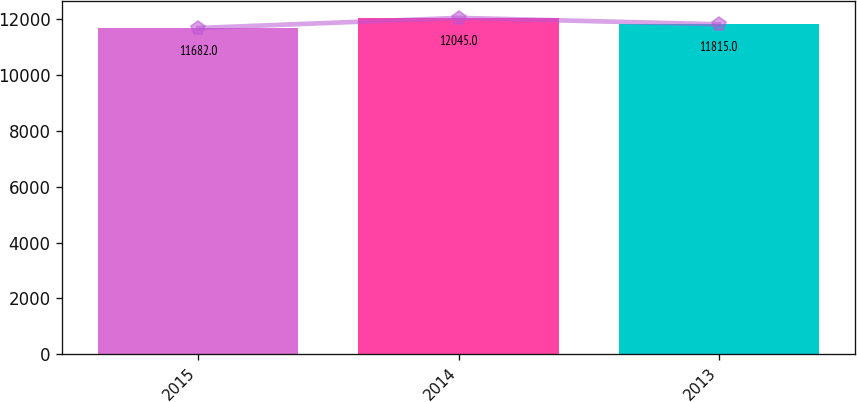Convert chart. <chart><loc_0><loc_0><loc_500><loc_500><bar_chart><fcel>2015<fcel>2014<fcel>2013<nl><fcel>11682<fcel>12045<fcel>11815<nl></chart> 